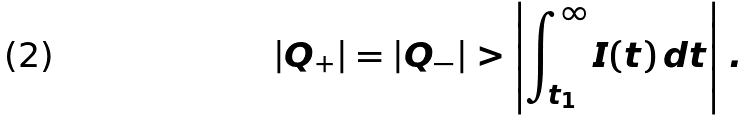<formula> <loc_0><loc_0><loc_500><loc_500>\left | Q _ { + } \right | = \left | Q _ { - } \right | > \left | \int ^ { \infty } _ { t _ { 1 } } I ( t ) \, d t \right | \, .</formula> 